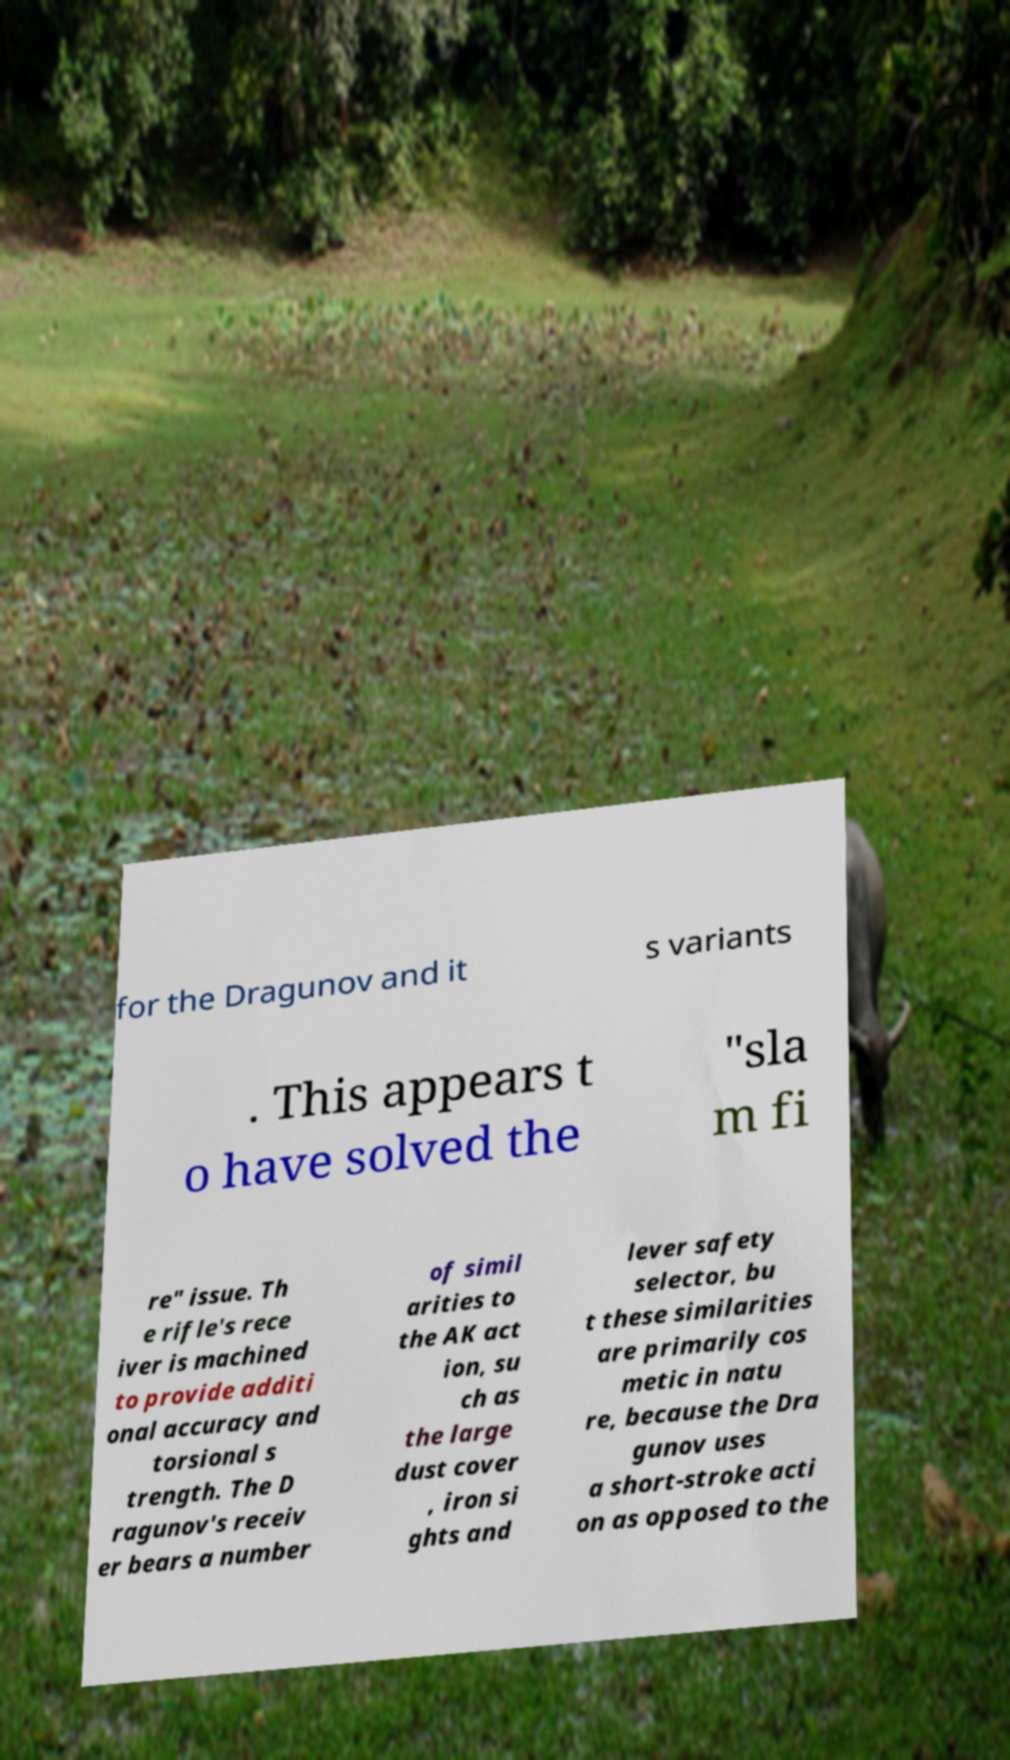What messages or text are displayed in this image? I need them in a readable, typed format. for the Dragunov and it s variants . This appears t o have solved the "sla m fi re" issue. Th e rifle's rece iver is machined to provide additi onal accuracy and torsional s trength. The D ragunov's receiv er bears a number of simil arities to the AK act ion, su ch as the large dust cover , iron si ghts and lever safety selector, bu t these similarities are primarily cos metic in natu re, because the Dra gunov uses a short-stroke acti on as opposed to the 